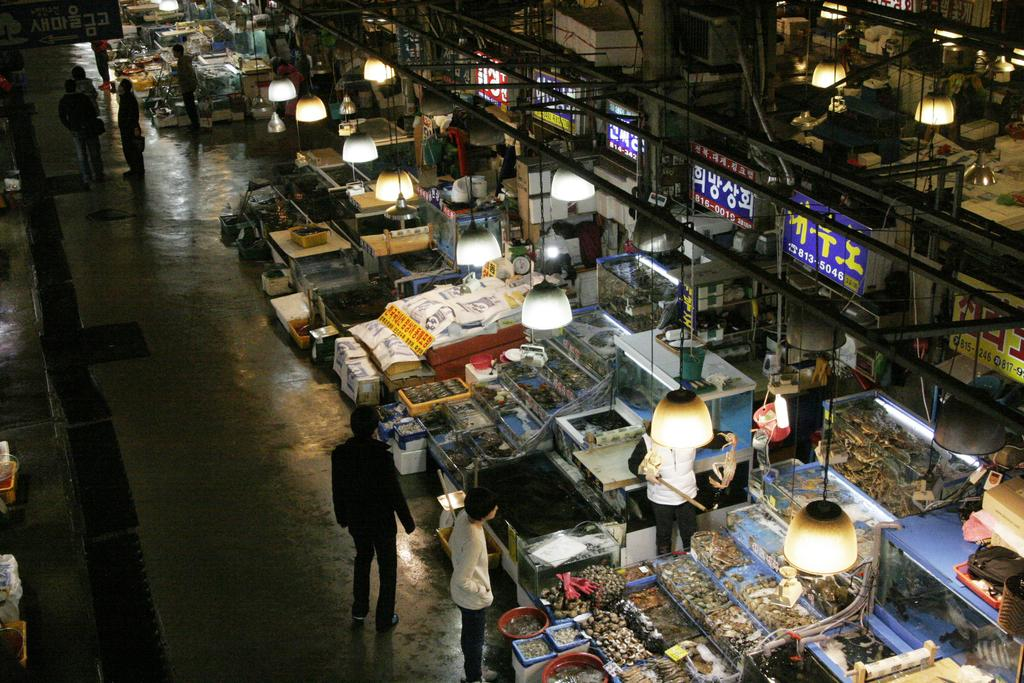What type of location is depicted in the image? The image appears to depict a market. What types of establishments can be seen in the market? There are stores visible in the image. Are there any people present in the image? Yes, there are people standing in the image. What can be seen illuminating the area in the image? Lights are present in the image. What type of signage is visible in the image? There are hoardings visible in the image. Can you see a duck walking with its partner in the image? There is no duck or partner present in the image. Is there any dirt visible on the ground in the image? The image does not show any dirt on the ground; it is not mentioned in the provided facts. 